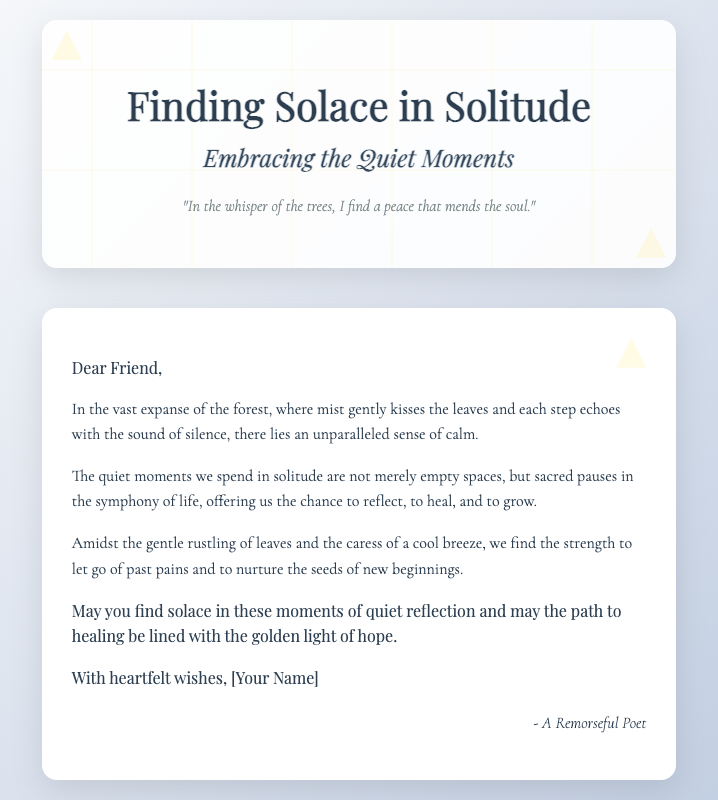what is the title of the card? The title of the card is prominently displayed near the top of the front section.
Answer: Finding Solace in Solitude who is the card addressed to? The greeting within the card specifies the recipient at the beginning.
Answer: Dear Friend what is the main theme of the card? The content and imagery throughout the card revolve around a specific central idea.
Answer: Solitude and healing how does the card suggest finding peace? The quote on the front captures a sentiment about achieving tranquility.
Answer: In the whisper of the trees what decorative elements are present on the front? The visuals on the front of the card include specific artistic features.
Answer: Leaves and sparkles what is the closing wish for the recipient? The final sentiment expresses what the author hopes for the reader's journey.
Answer: Solace in these moments of quiet reflection who is the author of the card? The signature at the bottom identifies the creator of the card.
Answer: A Remorseful Poet what color accents are used in the design? The description notes specific design elements that add to the aesthetic.
Answer: Gold 